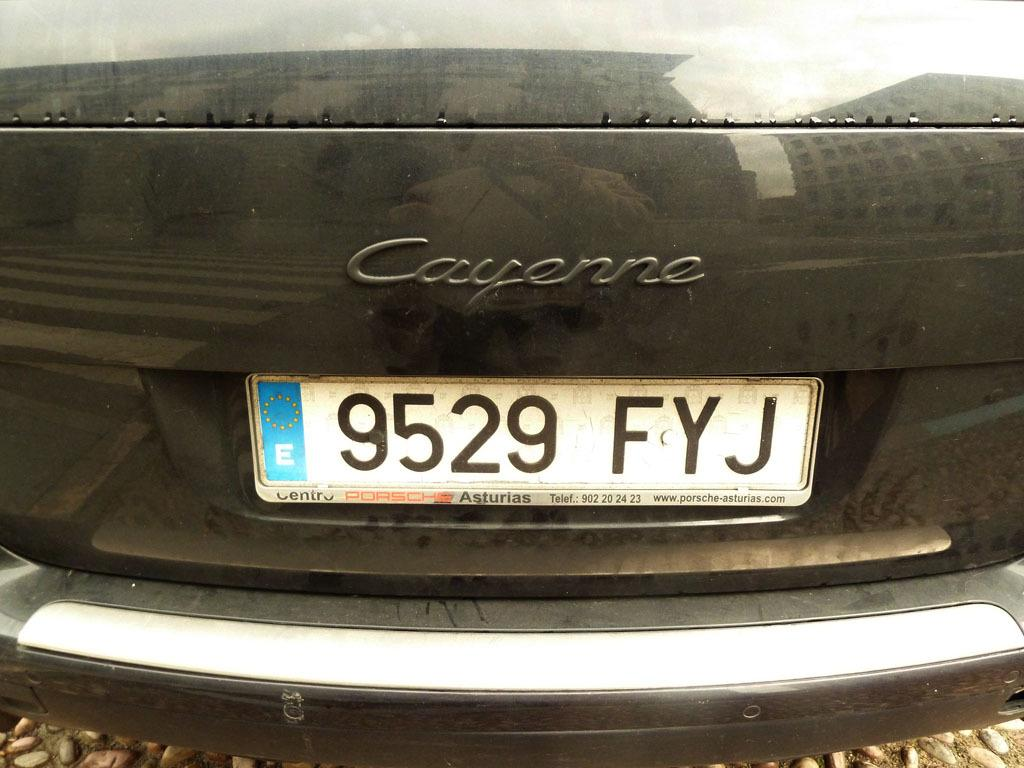<image>
Give a short and clear explanation of the subsequent image. A license plate 9529 FYJ on the back end of a Cayenne. 